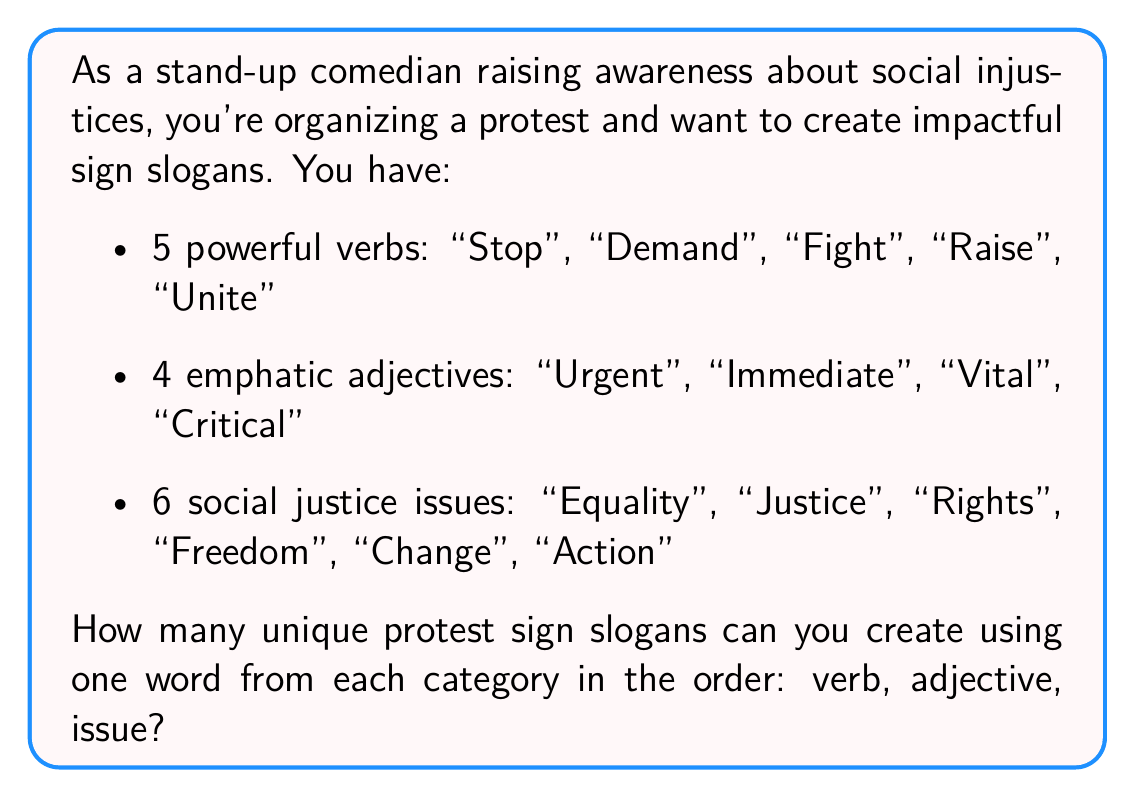Can you answer this question? To solve this problem, we'll use the multiplication principle of counting. This principle states that if we have a sequence of independent choices, the total number of possible outcomes is the product of the number of possibilities for each choice.

In this case, we have three independent choices:
1. Choosing a verb (5 options)
2. Choosing an adjective (4 options)
3. Choosing a social justice issue (6 options)

Each choice is independent of the others, meaning any verb can be paired with any adjective and any issue.

Therefore, the total number of unique slogans is:

$$ \text{Total slogans} = \text{Number of verbs} \times \text{Number of adjectives} \times \text{Number of issues} $$

$$ \text{Total slogans} = 5 \times 4 \times 6 $$

$$ \text{Total slogans} = 120 $$

This means you can create 120 unique protest sign slogans using the given words in the specified order.
Answer: $$ 120 \text{ unique protest sign slogans} $$ 